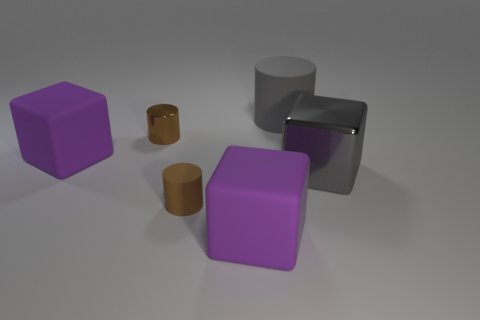Subtract all gray blocks. How many blocks are left? 2 Subtract all cyan cylinders. How many purple blocks are left? 2 Subtract all gray cylinders. How many cylinders are left? 2 Add 2 small purple things. How many objects exist? 8 Subtract all blue blocks. Subtract all green balls. How many blocks are left? 3 Subtract all big purple blocks. Subtract all big rubber blocks. How many objects are left? 2 Add 1 gray rubber cylinders. How many gray rubber cylinders are left? 2 Add 1 brown metallic cylinders. How many brown metallic cylinders exist? 2 Subtract 2 purple cubes. How many objects are left? 4 